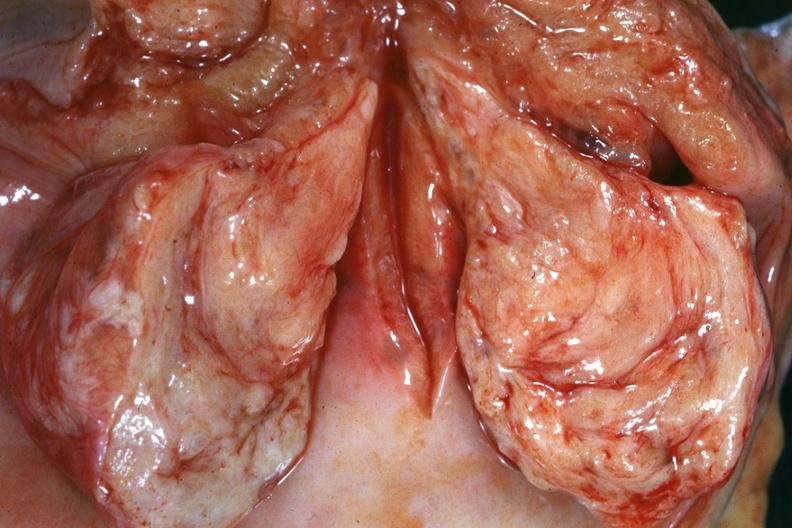s uterus present?
Answer the question using a single word or phrase. Yes 